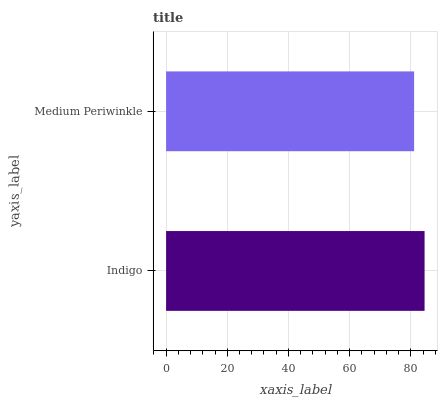Is Medium Periwinkle the minimum?
Answer yes or no. Yes. Is Indigo the maximum?
Answer yes or no. Yes. Is Medium Periwinkle the maximum?
Answer yes or no. No. Is Indigo greater than Medium Periwinkle?
Answer yes or no. Yes. Is Medium Periwinkle less than Indigo?
Answer yes or no. Yes. Is Medium Periwinkle greater than Indigo?
Answer yes or no. No. Is Indigo less than Medium Periwinkle?
Answer yes or no. No. Is Indigo the high median?
Answer yes or no. Yes. Is Medium Periwinkle the low median?
Answer yes or no. Yes. Is Medium Periwinkle the high median?
Answer yes or no. No. Is Indigo the low median?
Answer yes or no. No. 